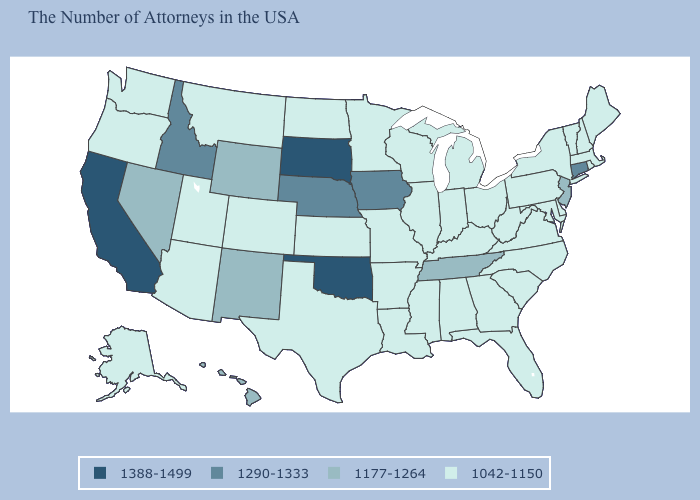Among the states that border Rhode Island , does Massachusetts have the lowest value?
Quick response, please. Yes. Name the states that have a value in the range 1042-1150?
Answer briefly. Maine, Massachusetts, Rhode Island, New Hampshire, Vermont, New York, Delaware, Maryland, Pennsylvania, Virginia, North Carolina, South Carolina, West Virginia, Ohio, Florida, Georgia, Michigan, Kentucky, Indiana, Alabama, Wisconsin, Illinois, Mississippi, Louisiana, Missouri, Arkansas, Minnesota, Kansas, Texas, North Dakota, Colorado, Utah, Montana, Arizona, Washington, Oregon, Alaska. Does Rhode Island have the same value as Nebraska?
Short answer required. No. Does the first symbol in the legend represent the smallest category?
Answer briefly. No. Among the states that border Missouri , which have the highest value?
Quick response, please. Oklahoma. What is the value of Nevada?
Keep it brief. 1177-1264. Among the states that border New Mexico , does Texas have the lowest value?
Answer briefly. Yes. What is the highest value in the USA?
Keep it brief. 1388-1499. What is the highest value in the Northeast ?
Answer briefly. 1290-1333. Does Georgia have the same value as South Carolina?
Concise answer only. Yes. Which states have the lowest value in the USA?
Answer briefly. Maine, Massachusetts, Rhode Island, New Hampshire, Vermont, New York, Delaware, Maryland, Pennsylvania, Virginia, North Carolina, South Carolina, West Virginia, Ohio, Florida, Georgia, Michigan, Kentucky, Indiana, Alabama, Wisconsin, Illinois, Mississippi, Louisiana, Missouri, Arkansas, Minnesota, Kansas, Texas, North Dakota, Colorado, Utah, Montana, Arizona, Washington, Oregon, Alaska. Does Nevada have a lower value than Tennessee?
Short answer required. No. Does Hawaii have the same value as Maryland?
Answer briefly. No. What is the value of South Dakota?
Short answer required. 1388-1499. 